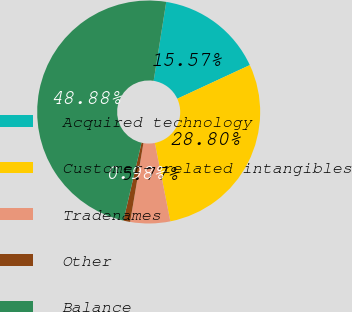Convert chart. <chart><loc_0><loc_0><loc_500><loc_500><pie_chart><fcel>Acquired technology<fcel>Customer- related intangibles<fcel>Tradenames<fcel>Other<fcel>Balance<nl><fcel>15.57%<fcel>28.8%<fcel>5.77%<fcel>0.98%<fcel>48.88%<nl></chart> 